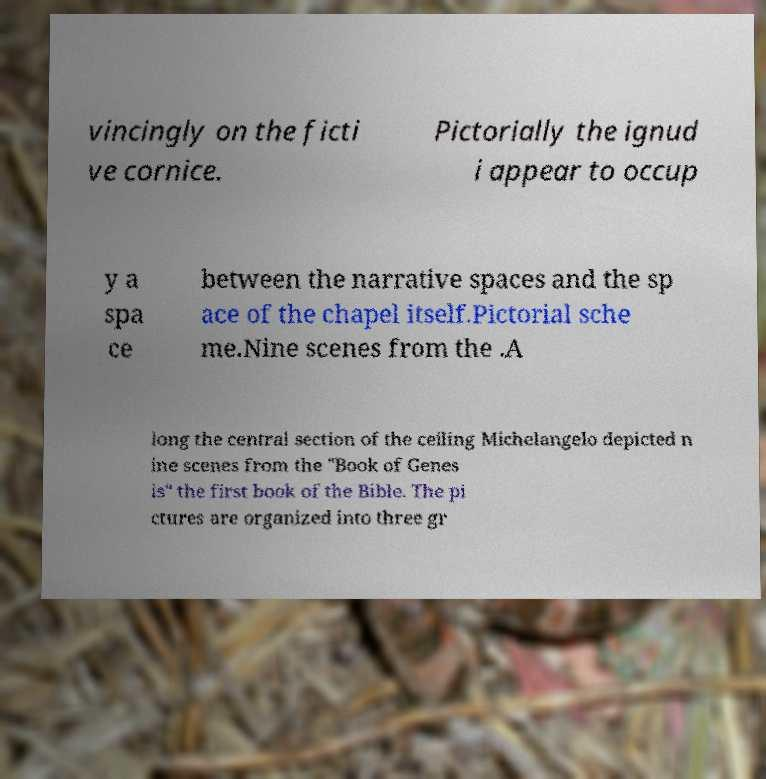Can you read and provide the text displayed in the image?This photo seems to have some interesting text. Can you extract and type it out for me? vincingly on the ficti ve cornice. Pictorially the ignud i appear to occup y a spa ce between the narrative spaces and the sp ace of the chapel itself.Pictorial sche me.Nine scenes from the .A long the central section of the ceiling Michelangelo depicted n ine scenes from the "Book of Genes is" the first book of the Bible. The pi ctures are organized into three gr 